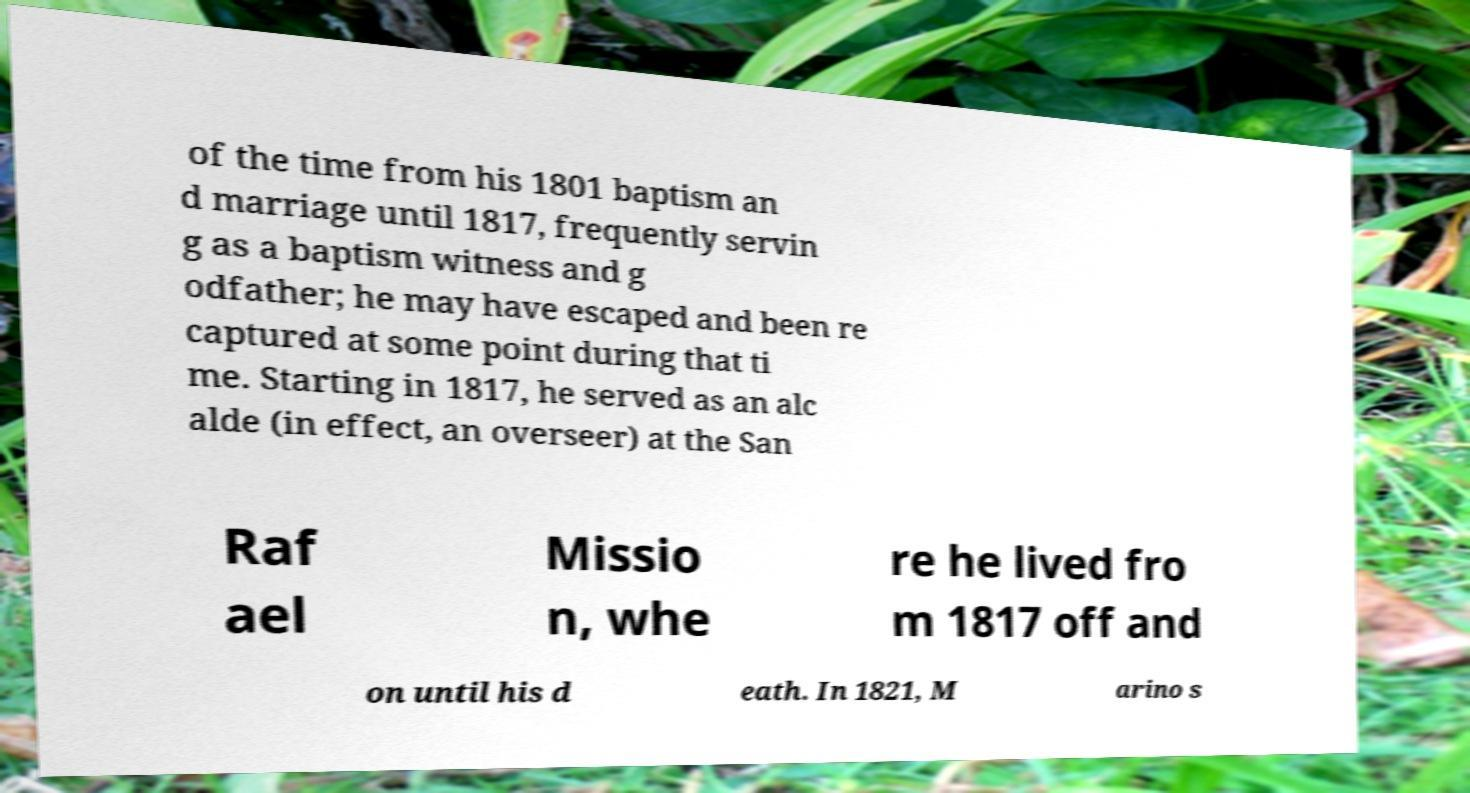I need the written content from this picture converted into text. Can you do that? of the time from his 1801 baptism an d marriage until 1817, frequently servin g as a baptism witness and g odfather; he may have escaped and been re captured at some point during that ti me. Starting in 1817, he served as an alc alde (in effect, an overseer) at the San Raf ael Missio n, whe re he lived fro m 1817 off and on until his d eath. In 1821, M arino s 